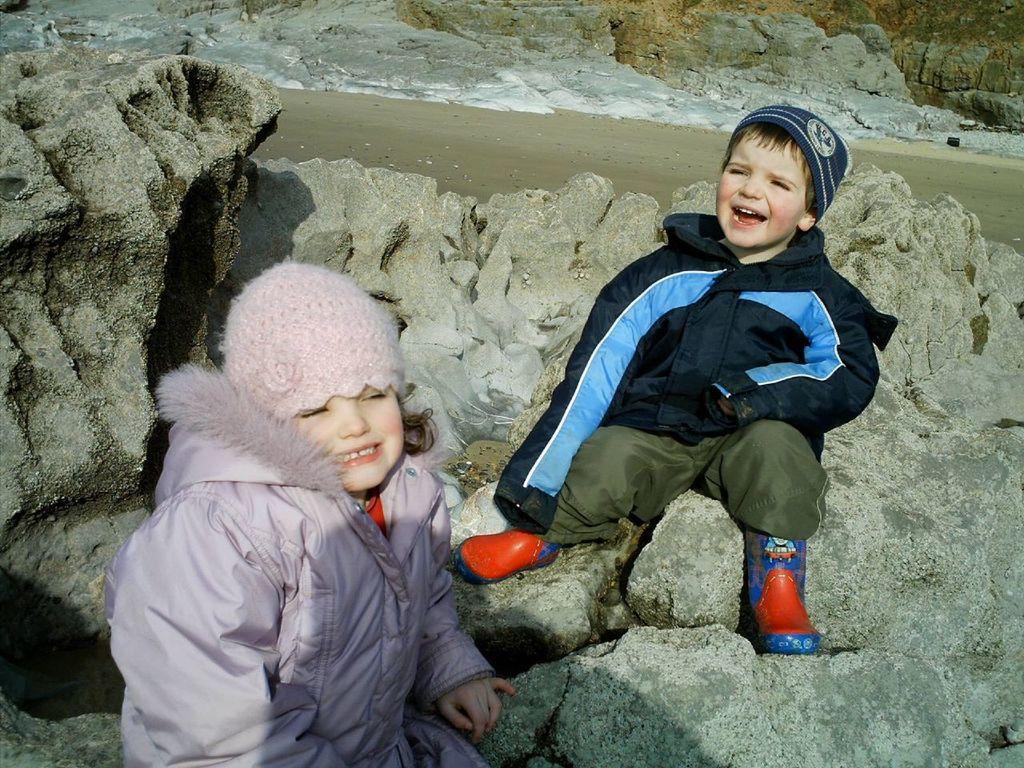Could you give a brief overview of what you see in this image? In this image we can see a boy and a girl wearing jackets and sitting on the rocks. In the background we can see soil and also water. 